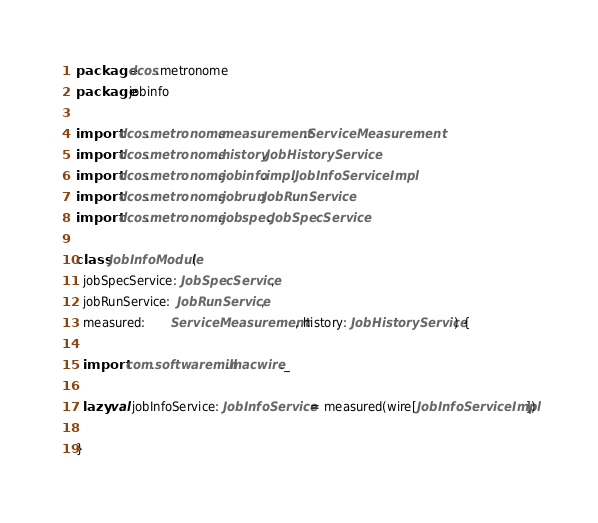<code> <loc_0><loc_0><loc_500><loc_500><_Scala_>package dcos.metronome
package jobinfo

import dcos.metronome.measurement.ServiceMeasurement
import dcos.metronome.history.JobHistoryService
import dcos.metronome.jobinfo.impl.JobInfoServiceImpl
import dcos.metronome.jobrun.JobRunService
import dcos.metronome.jobspec.JobSpecService

class JobInfoModule(
  jobSpecService: JobSpecService,
  jobRunService:  JobRunService,
  measured:       ServiceMeasurement, history: JobHistoryService) {

  import com.softwaremill.macwire._

  lazy val jobInfoService: JobInfoService = measured(wire[JobInfoServiceImpl])

}
</code> 